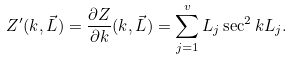Convert formula to latex. <formula><loc_0><loc_0><loc_500><loc_500>Z ^ { \prime } ( k , \vec { L } ) = \frac { \partial Z } { \partial k } ( k , \vec { L } ) = \sum _ { j = 1 } ^ { v } L _ { j } \sec ^ { 2 } k L _ { j } .</formula> 